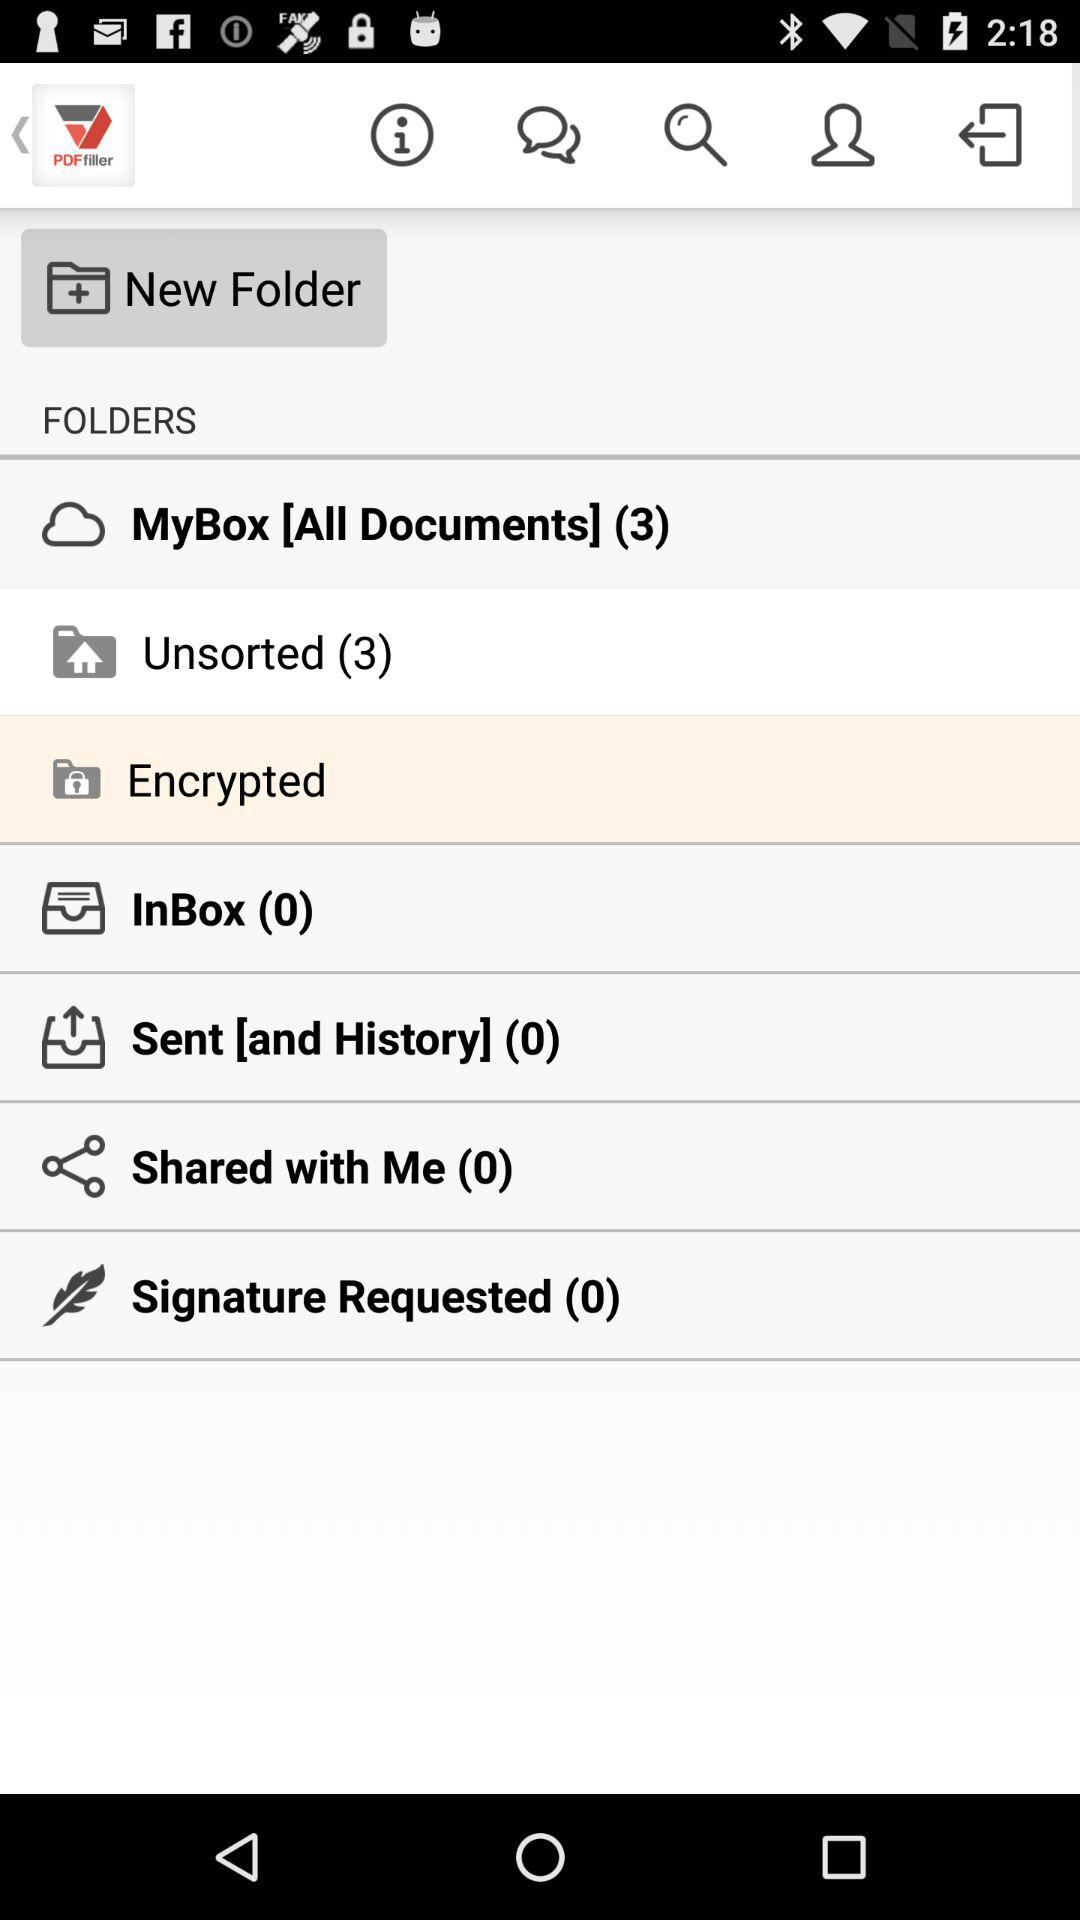Is there any message in sent?
When the provided information is insufficient, respond with <no answer>. <no answer> 